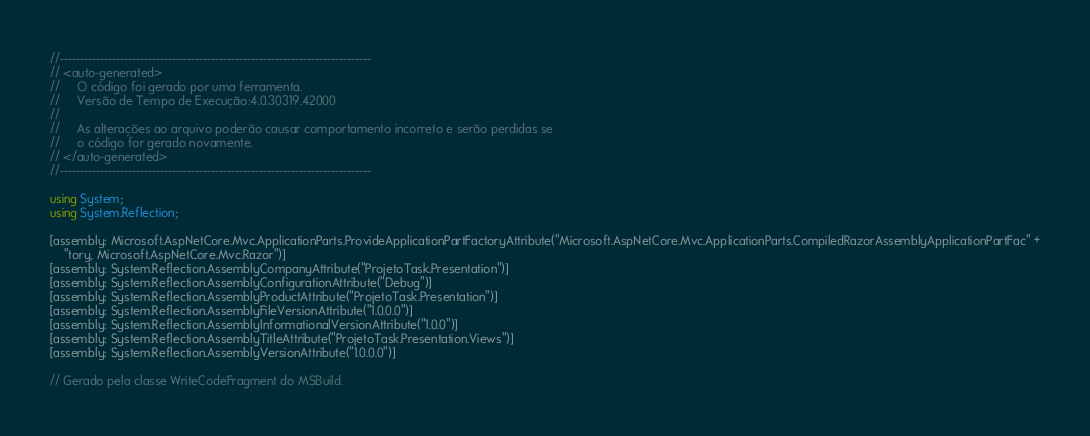<code> <loc_0><loc_0><loc_500><loc_500><_C#_>//------------------------------------------------------------------------------
// <auto-generated>
//     O código foi gerado por uma ferramenta.
//     Versão de Tempo de Execução:4.0.30319.42000
//
//     As alterações ao arquivo poderão causar comportamento incorreto e serão perdidas se
//     o código for gerado novamente.
// </auto-generated>
//------------------------------------------------------------------------------

using System;
using System.Reflection;

[assembly: Microsoft.AspNetCore.Mvc.ApplicationParts.ProvideApplicationPartFactoryAttribute("Microsoft.AspNetCore.Mvc.ApplicationParts.CompiledRazorAssemblyApplicationPartFac" +
    "tory, Microsoft.AspNetCore.Mvc.Razor")]
[assembly: System.Reflection.AssemblyCompanyAttribute("ProjetoTask.Presentation")]
[assembly: System.Reflection.AssemblyConfigurationAttribute("Debug")]
[assembly: System.Reflection.AssemblyProductAttribute("ProjetoTask.Presentation")]
[assembly: System.Reflection.AssemblyFileVersionAttribute("1.0.0.0")]
[assembly: System.Reflection.AssemblyInformationalVersionAttribute("1.0.0")]
[assembly: System.Reflection.AssemblyTitleAttribute("ProjetoTask.Presentation.Views")]
[assembly: System.Reflection.AssemblyVersionAttribute("1.0.0.0")]

// Gerado pela classe WriteCodeFragment do MSBuild.

</code> 